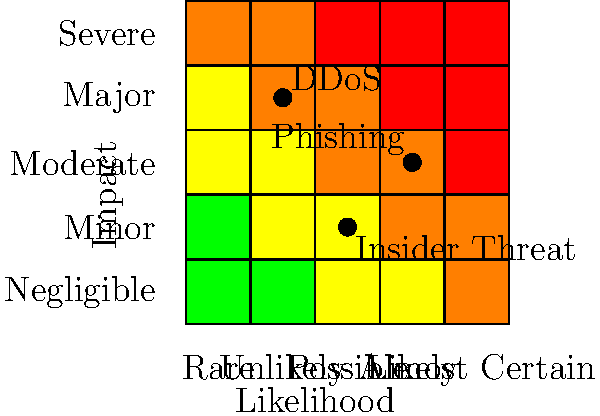As a CISO, you're tasked with analyzing the risk assessment matrix for various cyber threats. Based on the heat map visualization provided, which of the following statements is most accurate regarding the relative risk levels of DDoS attacks, phishing attempts, and insider threats? To answer this question, we need to analyze the position of each threat on the risk assessment matrix:

1. DDoS (Distributed Denial of Service) attacks:
   - Position: (1.5, 3.5)
   - Likelihood: Between "Unlikely" and "Possible"
   - Impact: Between "Major" and "Severe"
   - Risk level: High (red zone)

2. Phishing attempts:
   - Position: (3.5, 2.5)
   - Likelihood: Between "Likely" and "Almost Certain"
   - Impact: Between "Moderate" and "Major"
   - Risk level: High (red zone)

3. Insider threats:
   - Position: (2.5, 1.5)
   - Likelihood: "Possible"
   - Impact: Between "Minor" and "Moderate"
   - Risk level: Medium (yellow zone)

Comparing the positions:
- DDoS attacks have the highest potential impact but lower likelihood.
- Phishing attempts have the highest likelihood but slightly lower impact than DDoS.
- Insider threats have lower impact and moderate likelihood.

Both DDoS and phishing are in the high-risk (red) zone, while insider threats are in the medium-risk (yellow) zone.

The most accurate statement would be one that acknowledges the high risk of both DDoS and phishing, with insider threats presenting a comparatively lower risk.
Answer: DDoS and phishing pose high risks, while insider threats present a medium risk. 